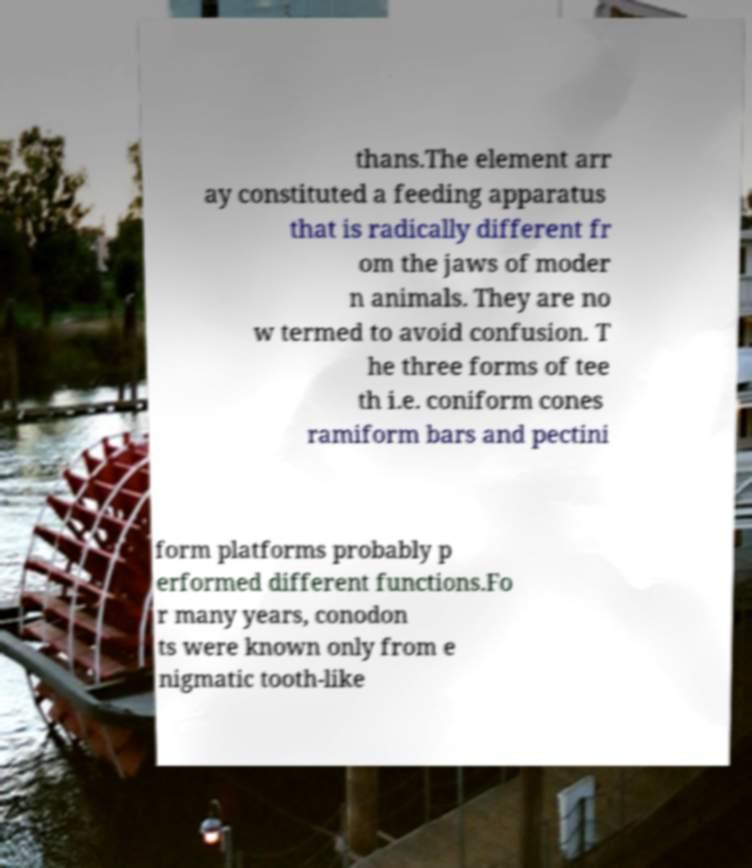There's text embedded in this image that I need extracted. Can you transcribe it verbatim? thans.The element arr ay constituted a feeding apparatus that is radically different fr om the jaws of moder n animals. They are no w termed to avoid confusion. T he three forms of tee th i.e. coniform cones ramiform bars and pectini form platforms probably p erformed different functions.Fo r many years, conodon ts were known only from e nigmatic tooth-like 